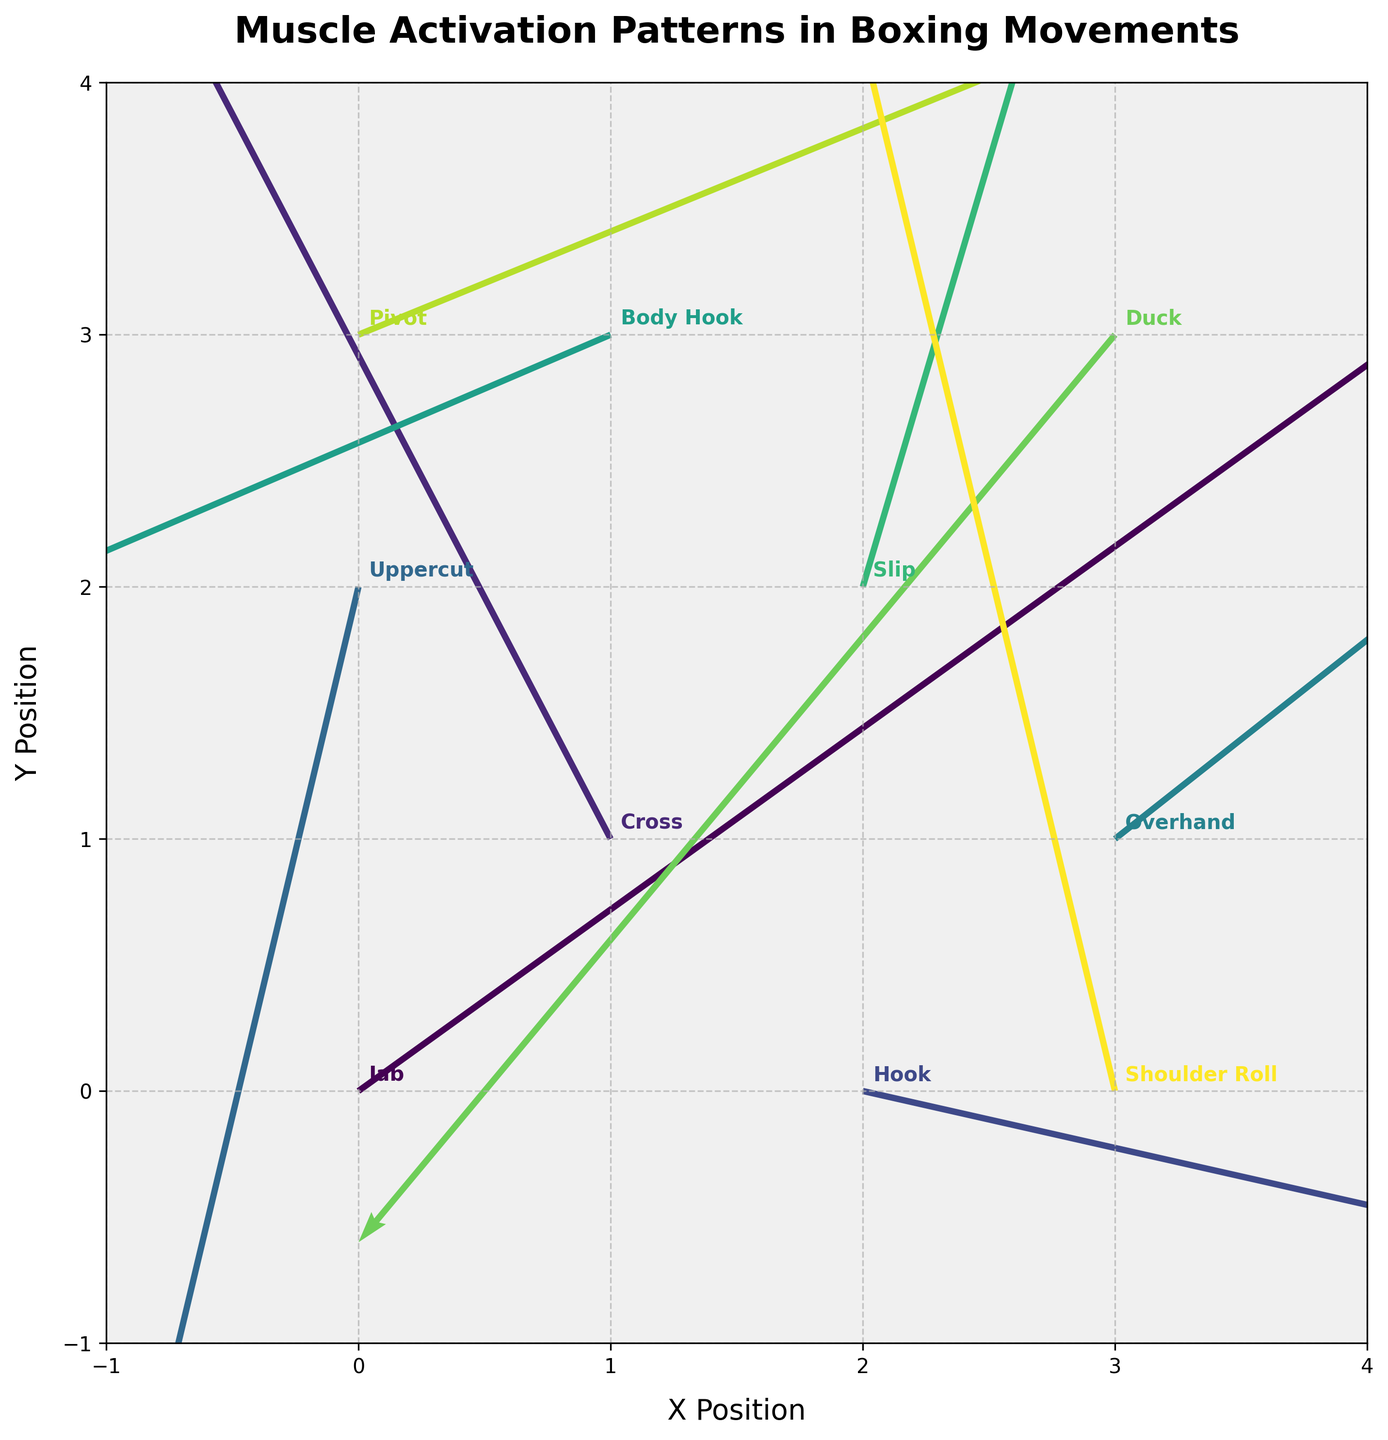What is the title of the plot? The title of the plot is located at the top center, stating what the plot is about in bold and larger text.
Answer: Muscle Activation Patterns in Boxing Movements How many distinct boxing movements are shown in the plot? There are 10 different quiver arrows each labeled with a unique boxing movement, as seen next to each arrow on the plot.
Answer: 10 Which movement has the highest horizontal component (u)? By checking the lengths and directions of the arrows in the plot, the largest rightward arrow (positive x-direction) comes from the movement "Hook".
Answer: Hook What is the horizontal displacement of the "Cross" movement? Locate the "Cross" movement in the plot, and note the horizontal component u, which indicates the displacement along the x-axis.
Answer: -1.2 Which movement has the highest vertical component (v)? The movement with the longest arrow pointing upward (positive y-direction) is identified as having the highest vertical component, which is "Slip".
Answer: Slip Compare the direction of "Pivot" and "Shoulder Roll" movements. Which one moves more upward? Check the vertical components (v) of the arrows for both movements. "Pivot" points slightly up whereas "Shoulder Roll" has a significant upward component.
Answer: Shoulder Roll What is the overall visual appearance and color scheme of the plot? The plot uses a gradient color scheme ranging from dark to bright colors, with a grey background and grid lines, aimed at making the quiver arrows noticeably distinct.
Answer: Gradient colors with grey background What are the x and y limits of the plot? The plot limits for both the x and y axes are displayed by the marked edges, which range from -1 to 4.
Answer: -1 to 4 (both axes) Which movement has the steepest downwards slope and what is its slope value? Find the arrow pointing most downward and calculate its slope (v/u). The "Duck" movement has the most downward direction with components -1.8 (v) / -1.5 (u) which equals to 1.2.
Answer: Duck, 1.2 Which boxing movements exhibit a negative vertical displacement? Identify arrows pointing downward (negative y-direction). These movements include "Uppercut", "Body Hook", and "Duck".
Answer: Uppercut, Body Hook, Duck 